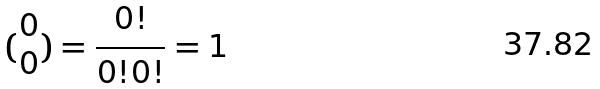<formula> <loc_0><loc_0><loc_500><loc_500>( \begin{matrix} 0 \\ 0 \end{matrix} ) = \frac { 0 ! } { 0 ! 0 ! } = 1</formula> 